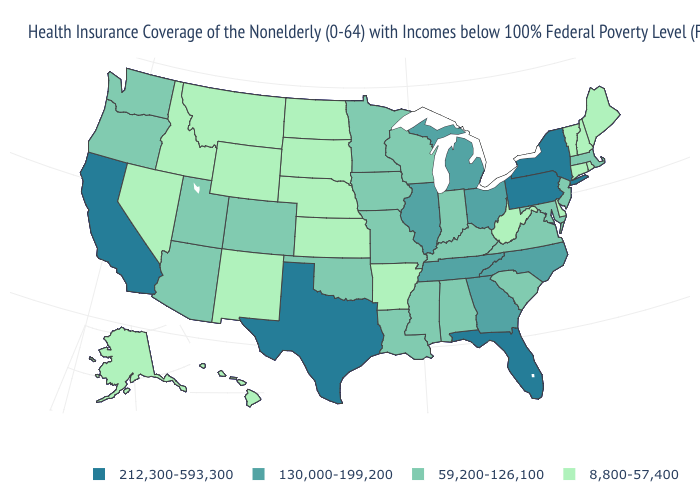How many symbols are there in the legend?
Write a very short answer. 4. Is the legend a continuous bar?
Keep it brief. No. Does Hawaii have the highest value in the West?
Write a very short answer. No. What is the lowest value in the West?
Short answer required. 8,800-57,400. Which states have the lowest value in the USA?
Concise answer only. Alaska, Arkansas, Connecticut, Delaware, Hawaii, Idaho, Kansas, Maine, Montana, Nebraska, Nevada, New Hampshire, New Mexico, North Dakota, Rhode Island, South Dakota, Vermont, West Virginia, Wyoming. What is the value of Wyoming?
Concise answer only. 8,800-57,400. What is the lowest value in the South?
Keep it brief. 8,800-57,400. Which states have the lowest value in the West?
Answer briefly. Alaska, Hawaii, Idaho, Montana, Nevada, New Mexico, Wyoming. What is the value of Georgia?
Concise answer only. 130,000-199,200. Name the states that have a value in the range 59,200-126,100?
Answer briefly. Alabama, Arizona, Colorado, Indiana, Iowa, Kentucky, Louisiana, Maryland, Massachusetts, Minnesota, Mississippi, Missouri, New Jersey, Oklahoma, Oregon, South Carolina, Utah, Virginia, Washington, Wisconsin. Does Nevada have the highest value in the USA?
Keep it brief. No. Among the states that border Iowa , which have the highest value?
Keep it brief. Illinois. Does the first symbol in the legend represent the smallest category?
Concise answer only. No. Name the states that have a value in the range 8,800-57,400?
Answer briefly. Alaska, Arkansas, Connecticut, Delaware, Hawaii, Idaho, Kansas, Maine, Montana, Nebraska, Nevada, New Hampshire, New Mexico, North Dakota, Rhode Island, South Dakota, Vermont, West Virginia, Wyoming. Name the states that have a value in the range 212,300-593,300?
Short answer required. California, Florida, New York, Pennsylvania, Texas. 